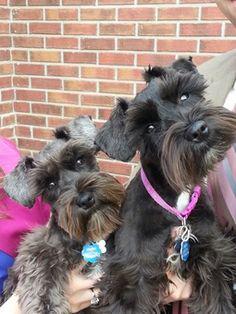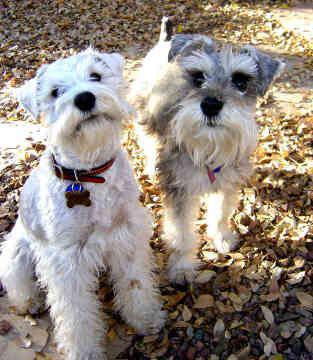The first image is the image on the left, the second image is the image on the right. Evaluate the accuracy of this statement regarding the images: "Both images show side-by-side schnauzer dogs with faces that look ahead instead of at the side.". Is it true? Answer yes or no. Yes. The first image is the image on the left, the second image is the image on the right. Examine the images to the left and right. Is the description "There are two lighter colored dogs and two darker colored dogs." accurate? Answer yes or no. Yes. 